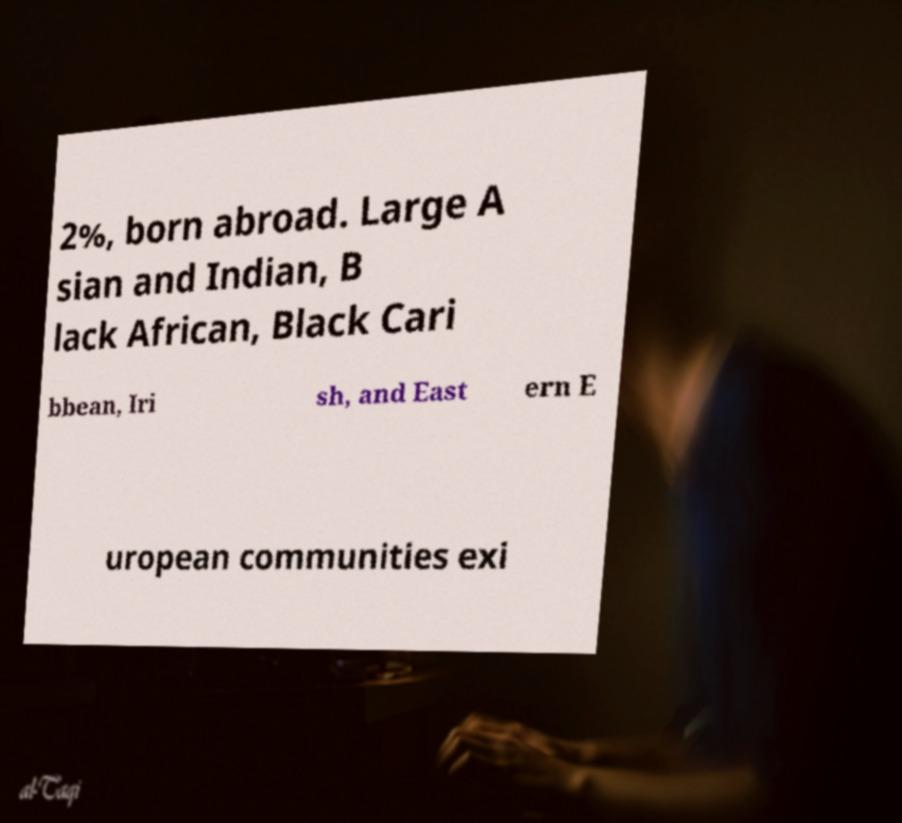Please read and relay the text visible in this image. What does it say? 2%, born abroad. Large A sian and Indian, B lack African, Black Cari bbean, Iri sh, and East ern E uropean communities exi 